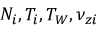<formula> <loc_0><loc_0><loc_500><loc_500>N _ { i } , T _ { i } , T _ { W } , \nu _ { z i }</formula> 